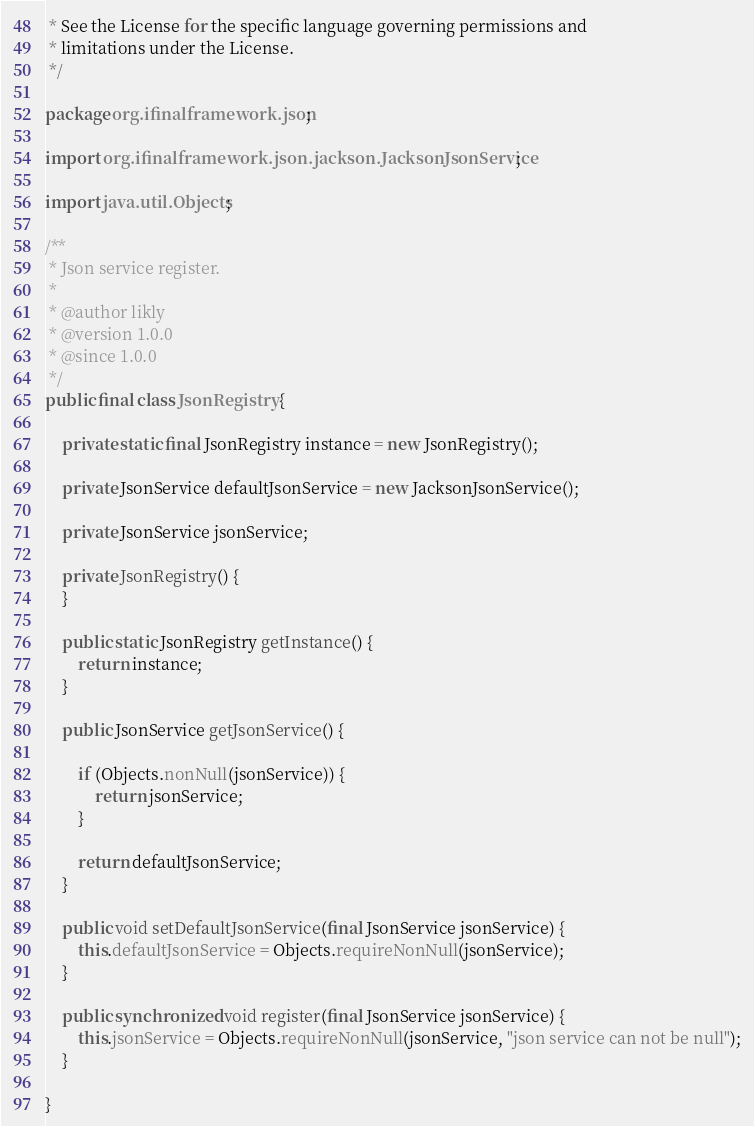<code> <loc_0><loc_0><loc_500><loc_500><_Java_> * See the License for the specific language governing permissions and
 * limitations under the License.
 */

package org.ifinalframework.json;

import org.ifinalframework.json.jackson.JacksonJsonService;

import java.util.Objects;

/**
 * Json service register.
 *
 * @author likly
 * @version 1.0.0
 * @since 1.0.0
 */
public final class JsonRegistry {

    private static final JsonRegistry instance = new JsonRegistry();

    private JsonService defaultJsonService = new JacksonJsonService();

    private JsonService jsonService;

    private JsonRegistry() {
    }

    public static JsonRegistry getInstance() {
        return instance;
    }

    public JsonService getJsonService() {

        if (Objects.nonNull(jsonService)) {
            return jsonService;
        }

        return defaultJsonService;
    }

    public void setDefaultJsonService(final JsonService jsonService) {
        this.defaultJsonService = Objects.requireNonNull(jsonService);
    }

    public synchronized void register(final JsonService jsonService) {
        this.jsonService = Objects.requireNonNull(jsonService, "json service can not be null");
    }

}
</code> 